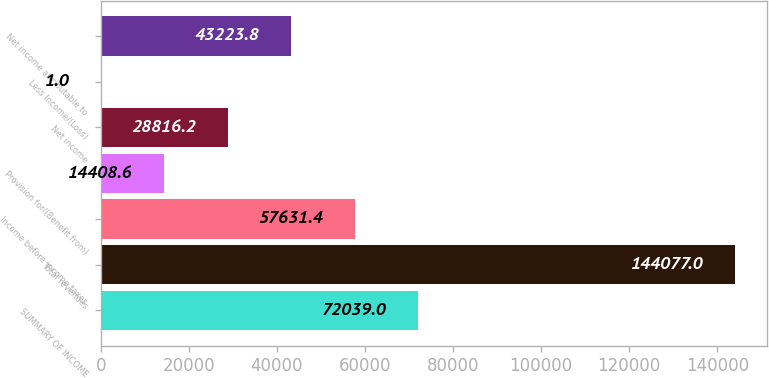Convert chart. <chart><loc_0><loc_0><loc_500><loc_500><bar_chart><fcel>SUMMARY OF INCOME<fcel>Total revenues<fcel>Income before income taxes<fcel>Provision for/(Benefit from)<fcel>Net income<fcel>Less Income/(Loss)<fcel>Net income attributable to<nl><fcel>72039<fcel>144077<fcel>57631.4<fcel>14408.6<fcel>28816.2<fcel>1<fcel>43223.8<nl></chart> 